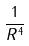Convert formula to latex. <formula><loc_0><loc_0><loc_500><loc_500>\frac { 1 } { R ^ { 4 } }</formula> 